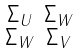Convert formula to latex. <formula><loc_0><loc_0><loc_500><loc_500>\begin{smallmatrix} \Sigma _ { U } & \Sigma _ { W } \\ \Sigma _ { W } & \Sigma _ { V } \end{smallmatrix}</formula> 